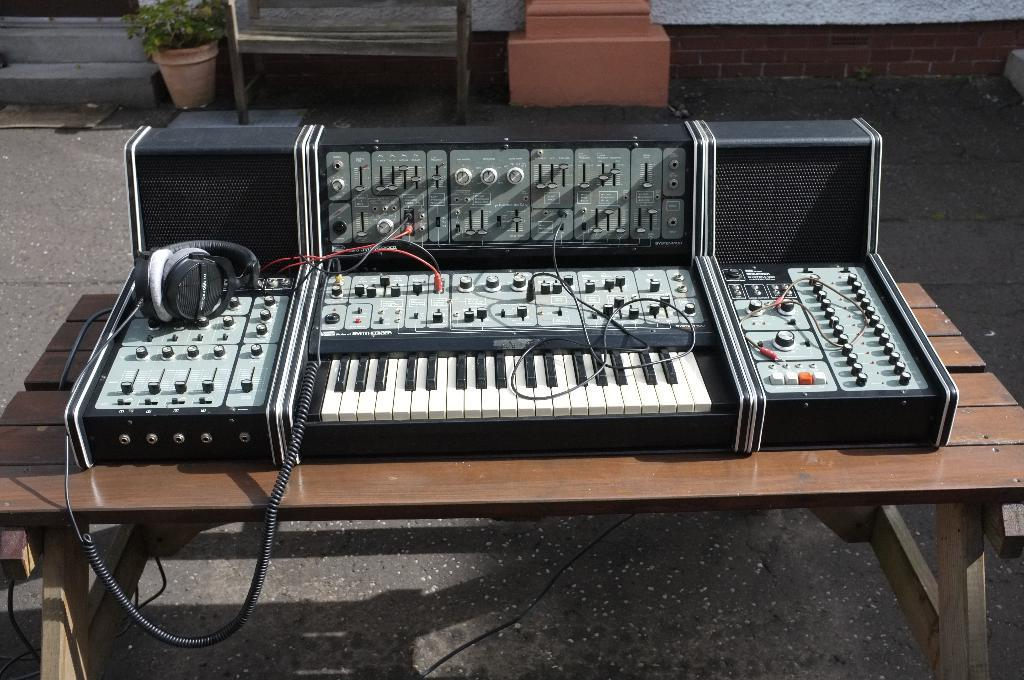What object related to music can be seen in the image? There is a musical instrument in the image. What device is present for listening to audio? There is a headphone in the image. Where are the musical instrument and headphone located? Both the musical instrument and headphone are on a table. What can be seen in the background of the image? There is a plant in the background of the image. Can you tell me how many friends are sitting next to the musical instrument in the image? There is no mention of friends or anyone sitting next to the musical instrument in the image. 